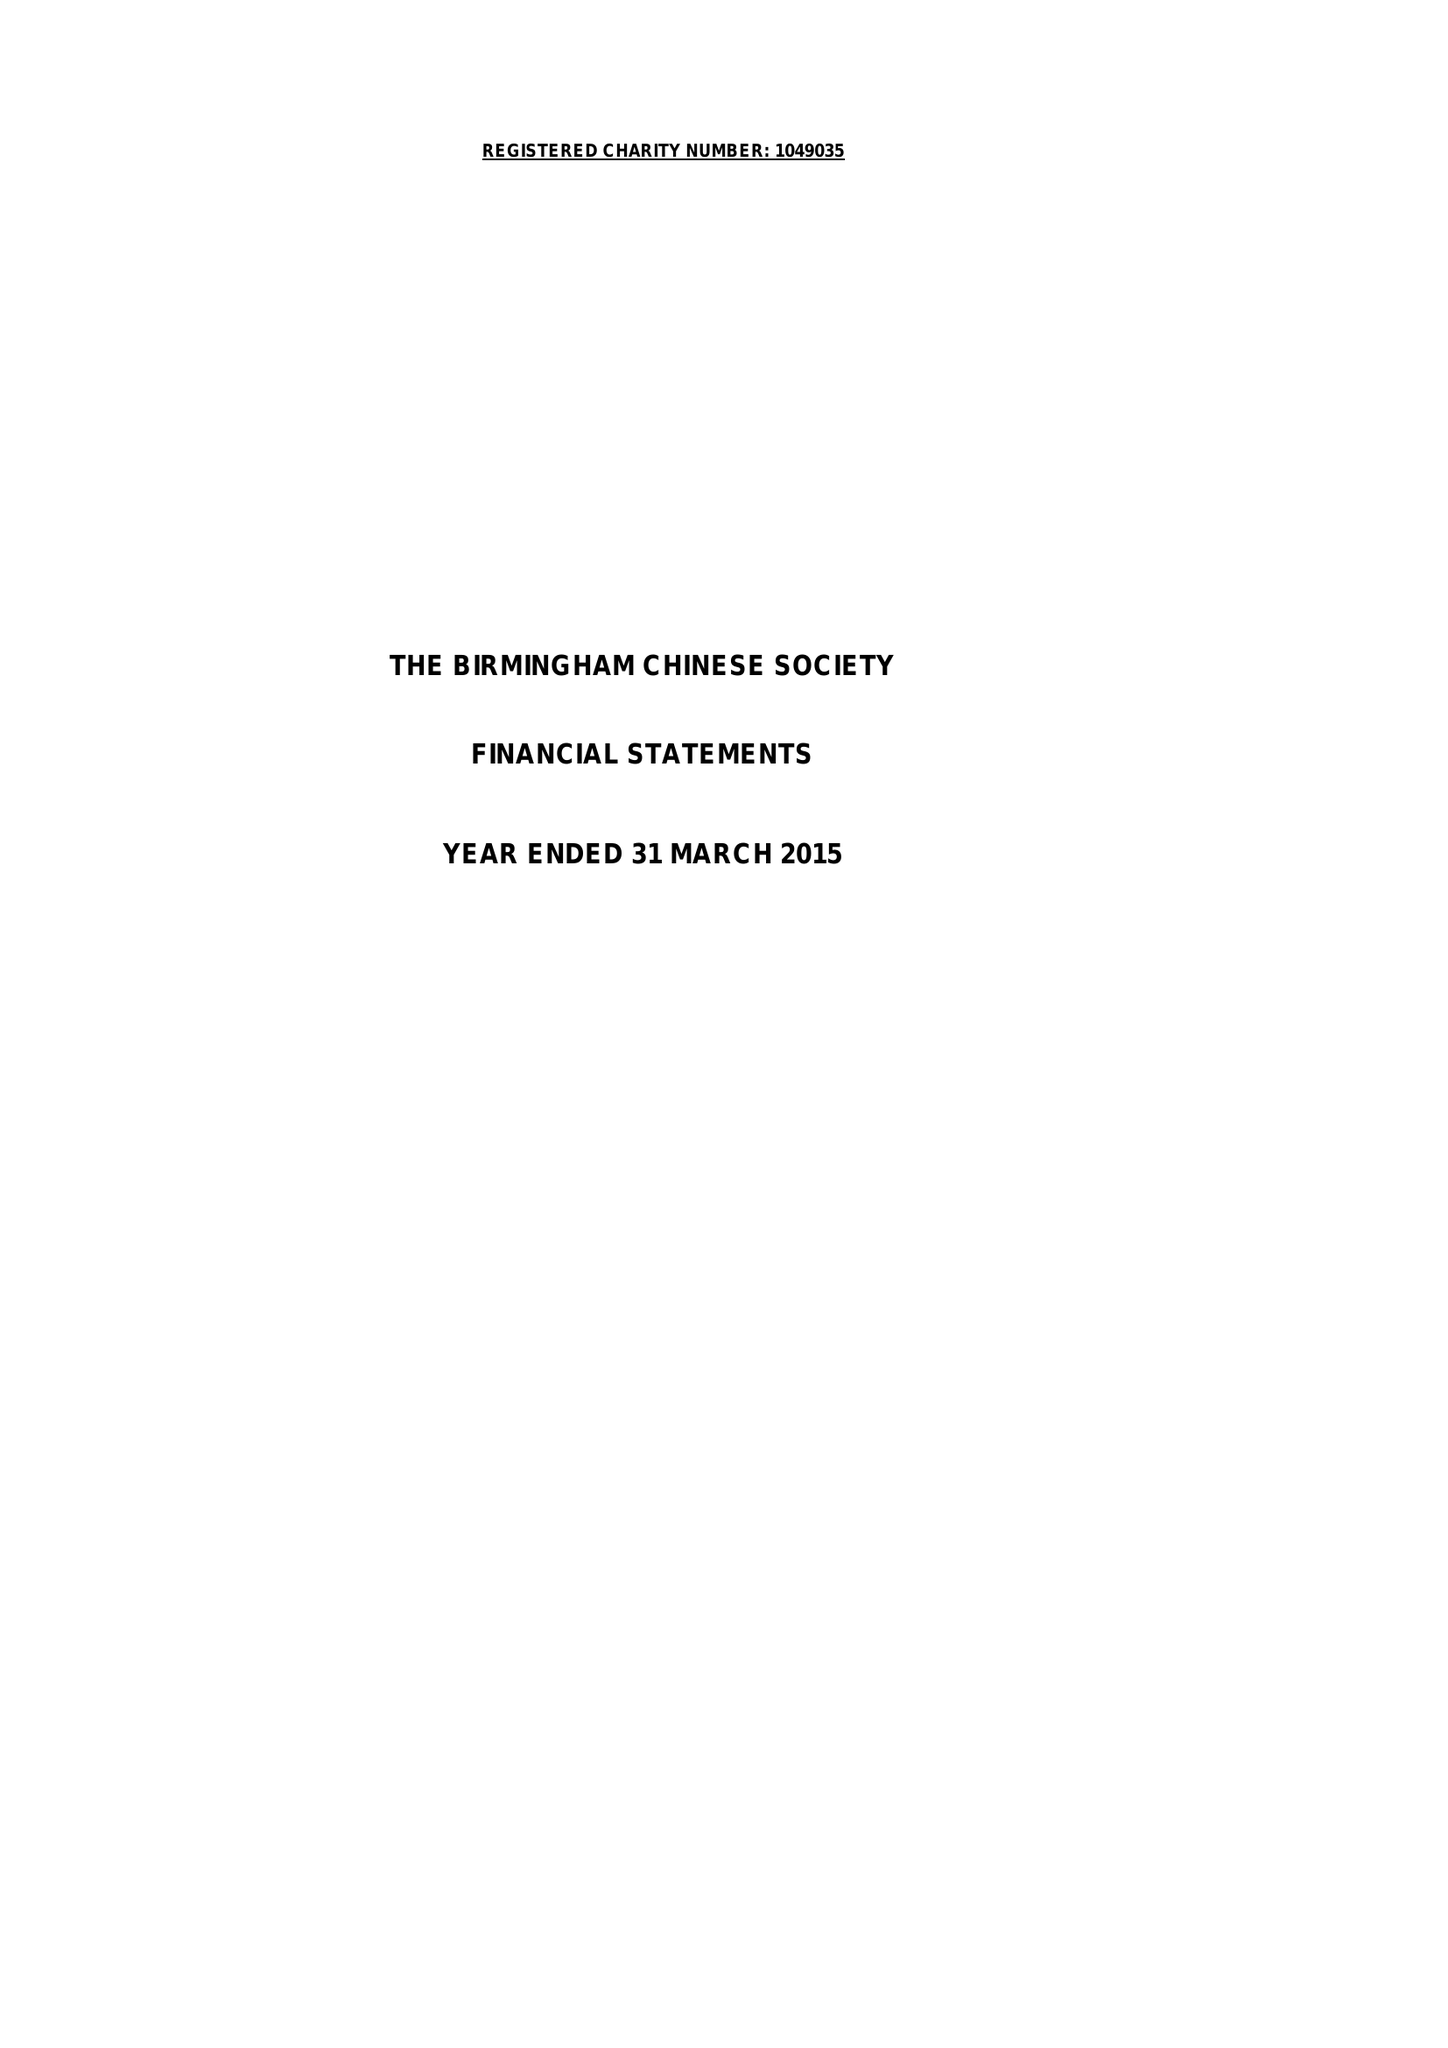What is the value for the address__postcode?
Answer the question using a single word or phrase. B9 4DY 